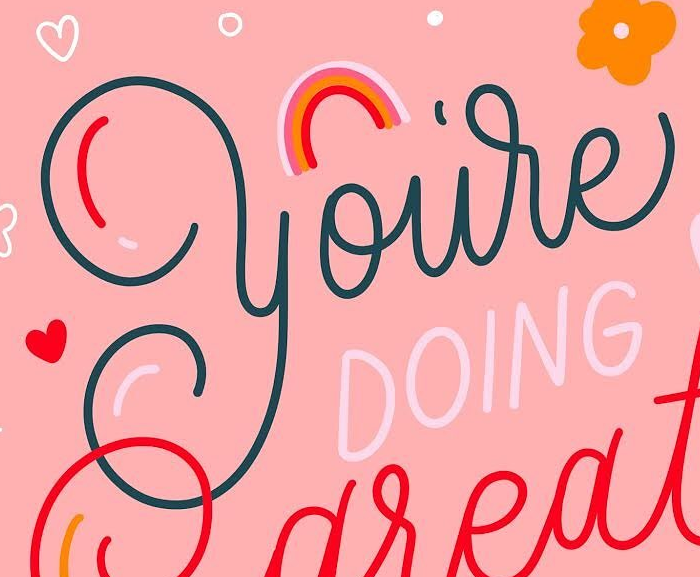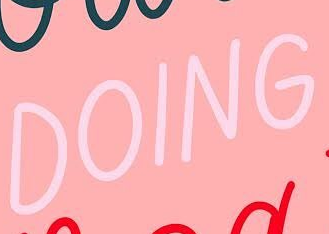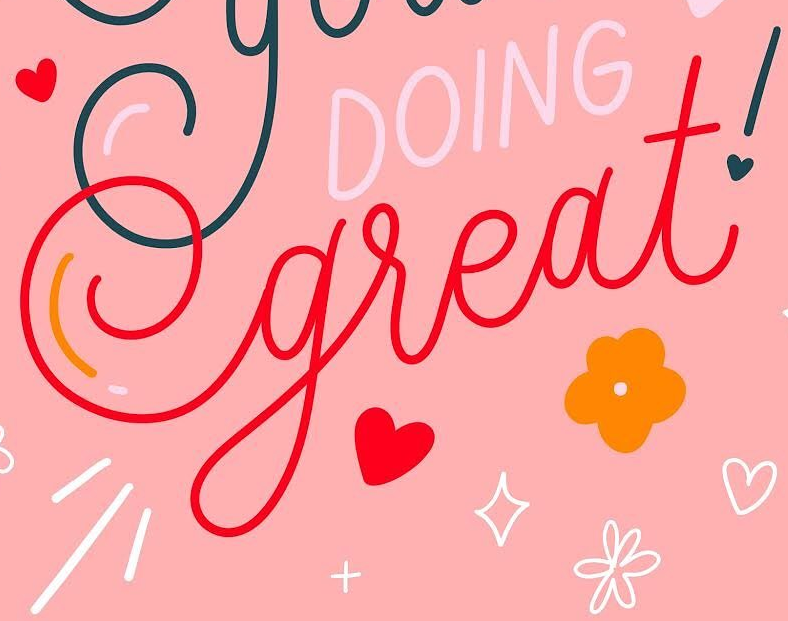Transcribe the words shown in these images in order, separated by a semicolon. you're; DOING; great! 